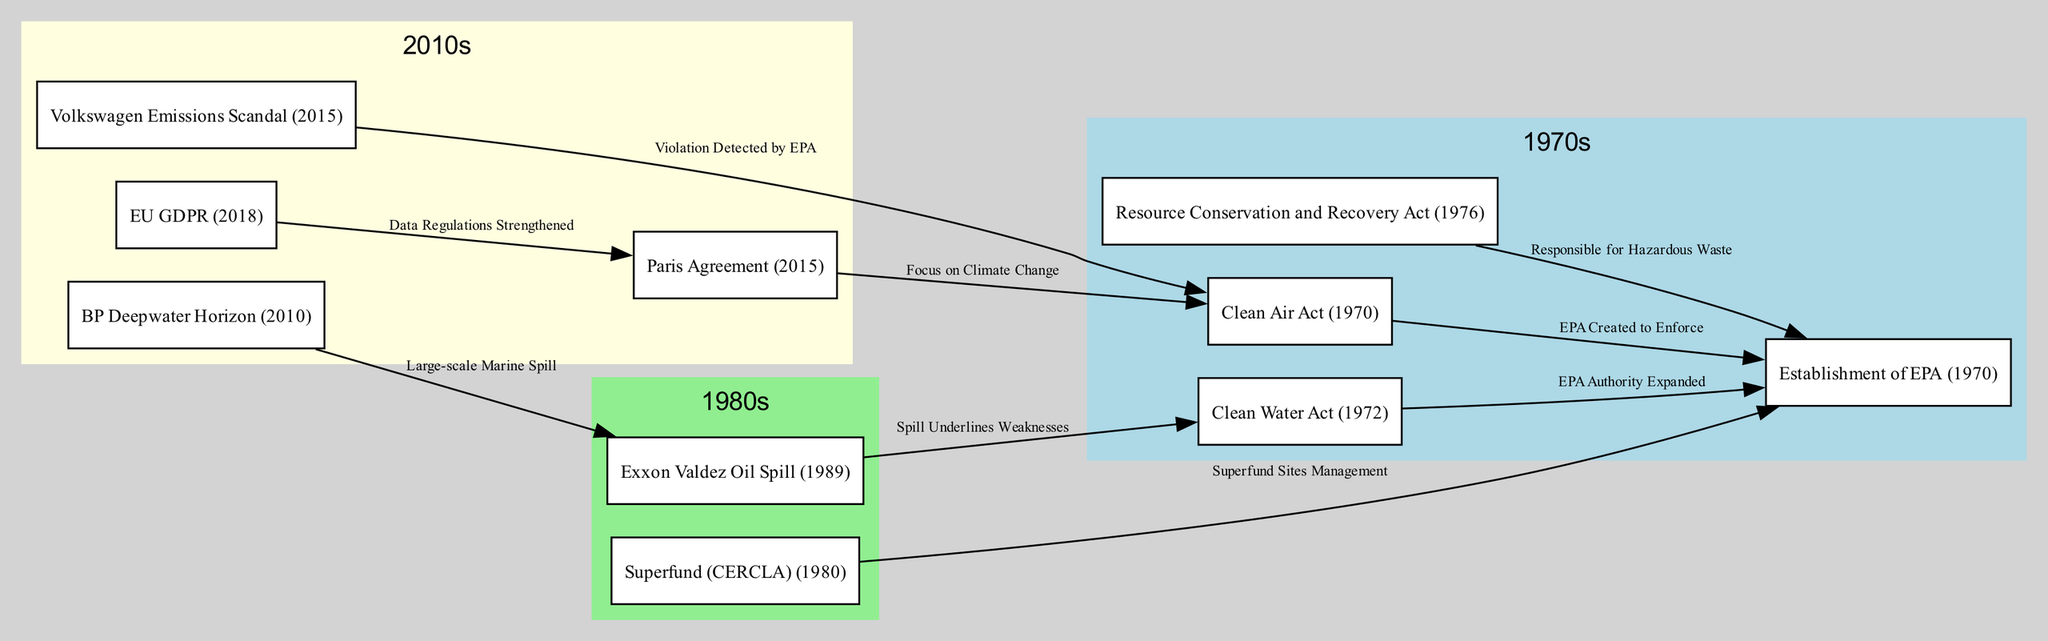What year was the Clean Water Act established? The Clean Water Act is listed as occurring in 1972 within the timeline of the diagram.
Answer: 1972 How many environmental regulations are mentioned in the diagram? The diagram includes 8 distinct environmental regulations, as represented by the nodes.
Answer: 8 What relationship does the Clean Air Act have with the establishment of the EPA? The diagram shows an edge labeled "EPA Created to Enforce" from the Clean Air Act to the EPA, indicating that the Clean Air Act led to the EPA's creation.
Answer: EPA Created to Enforce Which event is linked to identifying weaknesses in the Clean Water Act? The Exxon Valdez Oil Spill is connected to the Clean Water Act in the diagram with the label "Spill Underlines Weaknesses."
Answer: Exxon Valdez Oil Spill How many violations are directly associated with the Clean Air Act? The Clean Air Act has two direct violations associated with it: the Volkswagen Emissions Scandal and the connection to the Paris Agreement focusing on climate change.
Answer: 2 What was the significance of the BP Deepwater Horizon in relation to the Exxon Valdez? The diagram indicates a relationship with the label "Large-scale Marine Spill," suggesting that the BP Deepwater Horizon was a significant incident in the context of the Exxon Valdez spill.
Answer: Large-scale Marine Spill What year was the Superfund (CERCLA) established? The Superfund (CERCLA) is marked in the diagram as having been established in 1980.
Answer: 1980 What do the nodes in the 2010s cluster represent? The nodes in the 2010s cluster represent events and regulations related to environmental protection and corporate accountability during that decade, including the BP Deepwater Horizon, the Paris Agreement, the Volkswagen Emissions Scandal, and the GDPR.
Answer: BP Deepwater Horizon, Paris Agreement, VW Emission Scandal, GDPR 